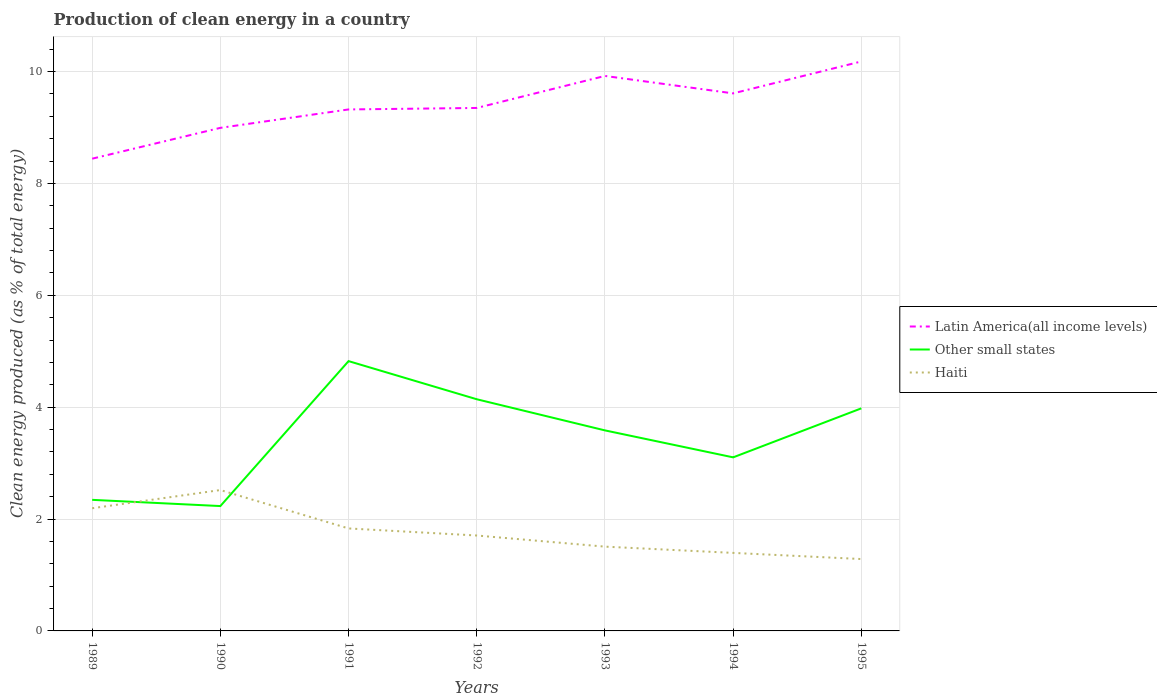Across all years, what is the maximum percentage of clean energy produced in Haiti?
Provide a succinct answer. 1.29. In which year was the percentage of clean energy produced in Latin America(all income levels) maximum?
Your answer should be compact. 1989. What is the total percentage of clean energy produced in Haiti in the graph?
Provide a short and direct response. 0.36. What is the difference between the highest and the second highest percentage of clean energy produced in Haiti?
Keep it short and to the point. 1.23. Is the percentage of clean energy produced in Other small states strictly greater than the percentage of clean energy produced in Latin America(all income levels) over the years?
Your answer should be compact. Yes. How many years are there in the graph?
Ensure brevity in your answer.  7. What is the difference between two consecutive major ticks on the Y-axis?
Your answer should be very brief. 2. Does the graph contain any zero values?
Offer a very short reply. No. Where does the legend appear in the graph?
Your response must be concise. Center right. How are the legend labels stacked?
Offer a very short reply. Vertical. What is the title of the graph?
Give a very brief answer. Production of clean energy in a country. What is the label or title of the Y-axis?
Your answer should be very brief. Clean energy produced (as % of total energy). What is the Clean energy produced (as % of total energy) of Latin America(all income levels) in 1989?
Give a very brief answer. 8.44. What is the Clean energy produced (as % of total energy) of Other small states in 1989?
Your answer should be very brief. 2.34. What is the Clean energy produced (as % of total energy) in Haiti in 1989?
Provide a short and direct response. 2.19. What is the Clean energy produced (as % of total energy) in Latin America(all income levels) in 1990?
Give a very brief answer. 8.99. What is the Clean energy produced (as % of total energy) of Other small states in 1990?
Ensure brevity in your answer.  2.23. What is the Clean energy produced (as % of total energy) in Haiti in 1990?
Your answer should be compact. 2.52. What is the Clean energy produced (as % of total energy) in Latin America(all income levels) in 1991?
Your answer should be compact. 9.32. What is the Clean energy produced (as % of total energy) in Other small states in 1991?
Make the answer very short. 4.82. What is the Clean energy produced (as % of total energy) in Haiti in 1991?
Your answer should be compact. 1.83. What is the Clean energy produced (as % of total energy) of Latin America(all income levels) in 1992?
Your answer should be very brief. 9.35. What is the Clean energy produced (as % of total energy) in Other small states in 1992?
Ensure brevity in your answer.  4.14. What is the Clean energy produced (as % of total energy) in Haiti in 1992?
Your answer should be compact. 1.71. What is the Clean energy produced (as % of total energy) in Latin America(all income levels) in 1993?
Your response must be concise. 9.92. What is the Clean energy produced (as % of total energy) of Other small states in 1993?
Your answer should be very brief. 3.59. What is the Clean energy produced (as % of total energy) in Haiti in 1993?
Your response must be concise. 1.51. What is the Clean energy produced (as % of total energy) of Latin America(all income levels) in 1994?
Ensure brevity in your answer.  9.61. What is the Clean energy produced (as % of total energy) in Other small states in 1994?
Keep it short and to the point. 3.1. What is the Clean energy produced (as % of total energy) of Haiti in 1994?
Your answer should be very brief. 1.39. What is the Clean energy produced (as % of total energy) of Latin America(all income levels) in 1995?
Offer a very short reply. 10.18. What is the Clean energy produced (as % of total energy) in Other small states in 1995?
Provide a short and direct response. 3.98. What is the Clean energy produced (as % of total energy) in Haiti in 1995?
Provide a short and direct response. 1.29. Across all years, what is the maximum Clean energy produced (as % of total energy) in Latin America(all income levels)?
Offer a very short reply. 10.18. Across all years, what is the maximum Clean energy produced (as % of total energy) in Other small states?
Your answer should be compact. 4.82. Across all years, what is the maximum Clean energy produced (as % of total energy) in Haiti?
Offer a terse response. 2.52. Across all years, what is the minimum Clean energy produced (as % of total energy) in Latin America(all income levels)?
Offer a very short reply. 8.44. Across all years, what is the minimum Clean energy produced (as % of total energy) in Other small states?
Provide a short and direct response. 2.23. Across all years, what is the minimum Clean energy produced (as % of total energy) of Haiti?
Offer a terse response. 1.29. What is the total Clean energy produced (as % of total energy) in Latin America(all income levels) in the graph?
Ensure brevity in your answer.  65.82. What is the total Clean energy produced (as % of total energy) of Other small states in the graph?
Provide a short and direct response. 24.21. What is the total Clean energy produced (as % of total energy) in Haiti in the graph?
Provide a succinct answer. 12.44. What is the difference between the Clean energy produced (as % of total energy) of Latin America(all income levels) in 1989 and that in 1990?
Give a very brief answer. -0.55. What is the difference between the Clean energy produced (as % of total energy) of Other small states in 1989 and that in 1990?
Keep it short and to the point. 0.11. What is the difference between the Clean energy produced (as % of total energy) of Haiti in 1989 and that in 1990?
Make the answer very short. -0.33. What is the difference between the Clean energy produced (as % of total energy) in Latin America(all income levels) in 1989 and that in 1991?
Offer a very short reply. -0.88. What is the difference between the Clean energy produced (as % of total energy) in Other small states in 1989 and that in 1991?
Offer a terse response. -2.48. What is the difference between the Clean energy produced (as % of total energy) in Haiti in 1989 and that in 1991?
Give a very brief answer. 0.36. What is the difference between the Clean energy produced (as % of total energy) of Latin America(all income levels) in 1989 and that in 1992?
Offer a very short reply. -0.91. What is the difference between the Clean energy produced (as % of total energy) in Other small states in 1989 and that in 1992?
Offer a terse response. -1.8. What is the difference between the Clean energy produced (as % of total energy) of Haiti in 1989 and that in 1992?
Your response must be concise. 0.49. What is the difference between the Clean energy produced (as % of total energy) in Latin America(all income levels) in 1989 and that in 1993?
Your answer should be very brief. -1.48. What is the difference between the Clean energy produced (as % of total energy) of Other small states in 1989 and that in 1993?
Keep it short and to the point. -1.24. What is the difference between the Clean energy produced (as % of total energy) of Haiti in 1989 and that in 1993?
Offer a very short reply. 0.69. What is the difference between the Clean energy produced (as % of total energy) of Latin America(all income levels) in 1989 and that in 1994?
Your answer should be compact. -1.17. What is the difference between the Clean energy produced (as % of total energy) of Other small states in 1989 and that in 1994?
Ensure brevity in your answer.  -0.76. What is the difference between the Clean energy produced (as % of total energy) in Haiti in 1989 and that in 1994?
Your answer should be compact. 0.8. What is the difference between the Clean energy produced (as % of total energy) of Latin America(all income levels) in 1989 and that in 1995?
Provide a succinct answer. -1.74. What is the difference between the Clean energy produced (as % of total energy) in Other small states in 1989 and that in 1995?
Give a very brief answer. -1.64. What is the difference between the Clean energy produced (as % of total energy) in Haiti in 1989 and that in 1995?
Provide a succinct answer. 0.91. What is the difference between the Clean energy produced (as % of total energy) of Latin America(all income levels) in 1990 and that in 1991?
Give a very brief answer. -0.33. What is the difference between the Clean energy produced (as % of total energy) of Other small states in 1990 and that in 1991?
Your answer should be very brief. -2.59. What is the difference between the Clean energy produced (as % of total energy) in Haiti in 1990 and that in 1991?
Make the answer very short. 0.69. What is the difference between the Clean energy produced (as % of total energy) in Latin America(all income levels) in 1990 and that in 1992?
Your response must be concise. -0.36. What is the difference between the Clean energy produced (as % of total energy) in Other small states in 1990 and that in 1992?
Your answer should be compact. -1.91. What is the difference between the Clean energy produced (as % of total energy) of Haiti in 1990 and that in 1992?
Keep it short and to the point. 0.81. What is the difference between the Clean energy produced (as % of total energy) in Latin America(all income levels) in 1990 and that in 1993?
Ensure brevity in your answer.  -0.93. What is the difference between the Clean energy produced (as % of total energy) in Other small states in 1990 and that in 1993?
Offer a very short reply. -1.35. What is the difference between the Clean energy produced (as % of total energy) of Haiti in 1990 and that in 1993?
Keep it short and to the point. 1.01. What is the difference between the Clean energy produced (as % of total energy) in Latin America(all income levels) in 1990 and that in 1994?
Keep it short and to the point. -0.62. What is the difference between the Clean energy produced (as % of total energy) in Other small states in 1990 and that in 1994?
Your response must be concise. -0.87. What is the difference between the Clean energy produced (as % of total energy) of Haiti in 1990 and that in 1994?
Give a very brief answer. 1.12. What is the difference between the Clean energy produced (as % of total energy) in Latin America(all income levels) in 1990 and that in 1995?
Ensure brevity in your answer.  -1.19. What is the difference between the Clean energy produced (as % of total energy) in Other small states in 1990 and that in 1995?
Your response must be concise. -1.75. What is the difference between the Clean energy produced (as % of total energy) of Haiti in 1990 and that in 1995?
Give a very brief answer. 1.23. What is the difference between the Clean energy produced (as % of total energy) of Latin America(all income levels) in 1991 and that in 1992?
Offer a terse response. -0.03. What is the difference between the Clean energy produced (as % of total energy) in Other small states in 1991 and that in 1992?
Make the answer very short. 0.68. What is the difference between the Clean energy produced (as % of total energy) of Haiti in 1991 and that in 1992?
Provide a succinct answer. 0.13. What is the difference between the Clean energy produced (as % of total energy) of Latin America(all income levels) in 1991 and that in 1993?
Offer a terse response. -0.6. What is the difference between the Clean energy produced (as % of total energy) of Other small states in 1991 and that in 1993?
Your answer should be compact. 1.24. What is the difference between the Clean energy produced (as % of total energy) of Haiti in 1991 and that in 1993?
Ensure brevity in your answer.  0.33. What is the difference between the Clean energy produced (as % of total energy) in Latin America(all income levels) in 1991 and that in 1994?
Offer a very short reply. -0.29. What is the difference between the Clean energy produced (as % of total energy) in Other small states in 1991 and that in 1994?
Provide a succinct answer. 1.72. What is the difference between the Clean energy produced (as % of total energy) of Haiti in 1991 and that in 1994?
Offer a terse response. 0.44. What is the difference between the Clean energy produced (as % of total energy) in Latin America(all income levels) in 1991 and that in 1995?
Offer a very short reply. -0.86. What is the difference between the Clean energy produced (as % of total energy) of Other small states in 1991 and that in 1995?
Offer a terse response. 0.84. What is the difference between the Clean energy produced (as % of total energy) of Haiti in 1991 and that in 1995?
Make the answer very short. 0.55. What is the difference between the Clean energy produced (as % of total energy) in Latin America(all income levels) in 1992 and that in 1993?
Provide a short and direct response. -0.57. What is the difference between the Clean energy produced (as % of total energy) of Other small states in 1992 and that in 1993?
Give a very brief answer. 0.56. What is the difference between the Clean energy produced (as % of total energy) of Haiti in 1992 and that in 1993?
Offer a terse response. 0.2. What is the difference between the Clean energy produced (as % of total energy) in Latin America(all income levels) in 1992 and that in 1994?
Offer a very short reply. -0.26. What is the difference between the Clean energy produced (as % of total energy) of Other small states in 1992 and that in 1994?
Ensure brevity in your answer.  1.04. What is the difference between the Clean energy produced (as % of total energy) of Haiti in 1992 and that in 1994?
Keep it short and to the point. 0.31. What is the difference between the Clean energy produced (as % of total energy) in Latin America(all income levels) in 1992 and that in 1995?
Keep it short and to the point. -0.83. What is the difference between the Clean energy produced (as % of total energy) of Other small states in 1992 and that in 1995?
Provide a short and direct response. 0.16. What is the difference between the Clean energy produced (as % of total energy) in Haiti in 1992 and that in 1995?
Offer a terse response. 0.42. What is the difference between the Clean energy produced (as % of total energy) in Latin America(all income levels) in 1993 and that in 1994?
Ensure brevity in your answer.  0.31. What is the difference between the Clean energy produced (as % of total energy) in Other small states in 1993 and that in 1994?
Offer a very short reply. 0.48. What is the difference between the Clean energy produced (as % of total energy) in Haiti in 1993 and that in 1994?
Make the answer very short. 0.11. What is the difference between the Clean energy produced (as % of total energy) in Latin America(all income levels) in 1993 and that in 1995?
Provide a succinct answer. -0.26. What is the difference between the Clean energy produced (as % of total energy) in Other small states in 1993 and that in 1995?
Keep it short and to the point. -0.39. What is the difference between the Clean energy produced (as % of total energy) of Haiti in 1993 and that in 1995?
Offer a terse response. 0.22. What is the difference between the Clean energy produced (as % of total energy) of Latin America(all income levels) in 1994 and that in 1995?
Ensure brevity in your answer.  -0.57. What is the difference between the Clean energy produced (as % of total energy) of Other small states in 1994 and that in 1995?
Offer a terse response. -0.88. What is the difference between the Clean energy produced (as % of total energy) in Haiti in 1994 and that in 1995?
Give a very brief answer. 0.11. What is the difference between the Clean energy produced (as % of total energy) in Latin America(all income levels) in 1989 and the Clean energy produced (as % of total energy) in Other small states in 1990?
Your answer should be compact. 6.21. What is the difference between the Clean energy produced (as % of total energy) in Latin America(all income levels) in 1989 and the Clean energy produced (as % of total energy) in Haiti in 1990?
Offer a very short reply. 5.92. What is the difference between the Clean energy produced (as % of total energy) in Other small states in 1989 and the Clean energy produced (as % of total energy) in Haiti in 1990?
Provide a short and direct response. -0.18. What is the difference between the Clean energy produced (as % of total energy) of Latin America(all income levels) in 1989 and the Clean energy produced (as % of total energy) of Other small states in 1991?
Your response must be concise. 3.62. What is the difference between the Clean energy produced (as % of total energy) in Latin America(all income levels) in 1989 and the Clean energy produced (as % of total energy) in Haiti in 1991?
Your answer should be compact. 6.61. What is the difference between the Clean energy produced (as % of total energy) in Other small states in 1989 and the Clean energy produced (as % of total energy) in Haiti in 1991?
Provide a succinct answer. 0.51. What is the difference between the Clean energy produced (as % of total energy) in Latin America(all income levels) in 1989 and the Clean energy produced (as % of total energy) in Other small states in 1992?
Your response must be concise. 4.3. What is the difference between the Clean energy produced (as % of total energy) in Latin America(all income levels) in 1989 and the Clean energy produced (as % of total energy) in Haiti in 1992?
Provide a succinct answer. 6.74. What is the difference between the Clean energy produced (as % of total energy) of Other small states in 1989 and the Clean energy produced (as % of total energy) of Haiti in 1992?
Your answer should be compact. 0.64. What is the difference between the Clean energy produced (as % of total energy) of Latin America(all income levels) in 1989 and the Clean energy produced (as % of total energy) of Other small states in 1993?
Provide a short and direct response. 4.86. What is the difference between the Clean energy produced (as % of total energy) of Latin America(all income levels) in 1989 and the Clean energy produced (as % of total energy) of Haiti in 1993?
Provide a short and direct response. 6.94. What is the difference between the Clean energy produced (as % of total energy) of Other small states in 1989 and the Clean energy produced (as % of total energy) of Haiti in 1993?
Offer a very short reply. 0.84. What is the difference between the Clean energy produced (as % of total energy) in Latin America(all income levels) in 1989 and the Clean energy produced (as % of total energy) in Other small states in 1994?
Make the answer very short. 5.34. What is the difference between the Clean energy produced (as % of total energy) in Latin America(all income levels) in 1989 and the Clean energy produced (as % of total energy) in Haiti in 1994?
Offer a terse response. 7.05. What is the difference between the Clean energy produced (as % of total energy) in Other small states in 1989 and the Clean energy produced (as % of total energy) in Haiti in 1994?
Ensure brevity in your answer.  0.95. What is the difference between the Clean energy produced (as % of total energy) in Latin America(all income levels) in 1989 and the Clean energy produced (as % of total energy) in Other small states in 1995?
Give a very brief answer. 4.46. What is the difference between the Clean energy produced (as % of total energy) of Latin America(all income levels) in 1989 and the Clean energy produced (as % of total energy) of Haiti in 1995?
Provide a succinct answer. 7.16. What is the difference between the Clean energy produced (as % of total energy) of Other small states in 1989 and the Clean energy produced (as % of total energy) of Haiti in 1995?
Make the answer very short. 1.06. What is the difference between the Clean energy produced (as % of total energy) of Latin America(all income levels) in 1990 and the Clean energy produced (as % of total energy) of Other small states in 1991?
Keep it short and to the point. 4.17. What is the difference between the Clean energy produced (as % of total energy) in Latin America(all income levels) in 1990 and the Clean energy produced (as % of total energy) in Haiti in 1991?
Give a very brief answer. 7.16. What is the difference between the Clean energy produced (as % of total energy) of Other small states in 1990 and the Clean energy produced (as % of total energy) of Haiti in 1991?
Provide a short and direct response. 0.4. What is the difference between the Clean energy produced (as % of total energy) in Latin America(all income levels) in 1990 and the Clean energy produced (as % of total energy) in Other small states in 1992?
Your answer should be compact. 4.85. What is the difference between the Clean energy produced (as % of total energy) in Latin America(all income levels) in 1990 and the Clean energy produced (as % of total energy) in Haiti in 1992?
Ensure brevity in your answer.  7.29. What is the difference between the Clean energy produced (as % of total energy) in Other small states in 1990 and the Clean energy produced (as % of total energy) in Haiti in 1992?
Offer a very short reply. 0.53. What is the difference between the Clean energy produced (as % of total energy) of Latin America(all income levels) in 1990 and the Clean energy produced (as % of total energy) of Other small states in 1993?
Provide a short and direct response. 5.41. What is the difference between the Clean energy produced (as % of total energy) in Latin America(all income levels) in 1990 and the Clean energy produced (as % of total energy) in Haiti in 1993?
Offer a terse response. 7.49. What is the difference between the Clean energy produced (as % of total energy) of Other small states in 1990 and the Clean energy produced (as % of total energy) of Haiti in 1993?
Give a very brief answer. 0.73. What is the difference between the Clean energy produced (as % of total energy) of Latin America(all income levels) in 1990 and the Clean energy produced (as % of total energy) of Other small states in 1994?
Your response must be concise. 5.89. What is the difference between the Clean energy produced (as % of total energy) in Latin America(all income levels) in 1990 and the Clean energy produced (as % of total energy) in Haiti in 1994?
Keep it short and to the point. 7.6. What is the difference between the Clean energy produced (as % of total energy) in Other small states in 1990 and the Clean energy produced (as % of total energy) in Haiti in 1994?
Ensure brevity in your answer.  0.84. What is the difference between the Clean energy produced (as % of total energy) of Latin America(all income levels) in 1990 and the Clean energy produced (as % of total energy) of Other small states in 1995?
Offer a very short reply. 5.01. What is the difference between the Clean energy produced (as % of total energy) of Latin America(all income levels) in 1990 and the Clean energy produced (as % of total energy) of Haiti in 1995?
Your answer should be very brief. 7.71. What is the difference between the Clean energy produced (as % of total energy) of Other small states in 1990 and the Clean energy produced (as % of total energy) of Haiti in 1995?
Keep it short and to the point. 0.95. What is the difference between the Clean energy produced (as % of total energy) in Latin America(all income levels) in 1991 and the Clean energy produced (as % of total energy) in Other small states in 1992?
Give a very brief answer. 5.18. What is the difference between the Clean energy produced (as % of total energy) in Latin America(all income levels) in 1991 and the Clean energy produced (as % of total energy) in Haiti in 1992?
Your answer should be compact. 7.62. What is the difference between the Clean energy produced (as % of total energy) in Other small states in 1991 and the Clean energy produced (as % of total energy) in Haiti in 1992?
Provide a short and direct response. 3.12. What is the difference between the Clean energy produced (as % of total energy) of Latin America(all income levels) in 1991 and the Clean energy produced (as % of total energy) of Other small states in 1993?
Provide a short and direct response. 5.74. What is the difference between the Clean energy produced (as % of total energy) in Latin America(all income levels) in 1991 and the Clean energy produced (as % of total energy) in Haiti in 1993?
Provide a succinct answer. 7.82. What is the difference between the Clean energy produced (as % of total energy) of Other small states in 1991 and the Clean energy produced (as % of total energy) of Haiti in 1993?
Your answer should be compact. 3.32. What is the difference between the Clean energy produced (as % of total energy) of Latin America(all income levels) in 1991 and the Clean energy produced (as % of total energy) of Other small states in 1994?
Your answer should be compact. 6.22. What is the difference between the Clean energy produced (as % of total energy) in Latin America(all income levels) in 1991 and the Clean energy produced (as % of total energy) in Haiti in 1994?
Your response must be concise. 7.93. What is the difference between the Clean energy produced (as % of total energy) of Other small states in 1991 and the Clean energy produced (as % of total energy) of Haiti in 1994?
Keep it short and to the point. 3.43. What is the difference between the Clean energy produced (as % of total energy) of Latin America(all income levels) in 1991 and the Clean energy produced (as % of total energy) of Other small states in 1995?
Offer a very short reply. 5.34. What is the difference between the Clean energy produced (as % of total energy) in Latin America(all income levels) in 1991 and the Clean energy produced (as % of total energy) in Haiti in 1995?
Offer a very short reply. 8.04. What is the difference between the Clean energy produced (as % of total energy) of Other small states in 1991 and the Clean energy produced (as % of total energy) of Haiti in 1995?
Keep it short and to the point. 3.54. What is the difference between the Clean energy produced (as % of total energy) of Latin America(all income levels) in 1992 and the Clean energy produced (as % of total energy) of Other small states in 1993?
Your answer should be compact. 5.76. What is the difference between the Clean energy produced (as % of total energy) of Latin America(all income levels) in 1992 and the Clean energy produced (as % of total energy) of Haiti in 1993?
Make the answer very short. 7.84. What is the difference between the Clean energy produced (as % of total energy) of Other small states in 1992 and the Clean energy produced (as % of total energy) of Haiti in 1993?
Provide a short and direct response. 2.63. What is the difference between the Clean energy produced (as % of total energy) in Latin America(all income levels) in 1992 and the Clean energy produced (as % of total energy) in Other small states in 1994?
Offer a terse response. 6.25. What is the difference between the Clean energy produced (as % of total energy) of Latin America(all income levels) in 1992 and the Clean energy produced (as % of total energy) of Haiti in 1994?
Your response must be concise. 7.95. What is the difference between the Clean energy produced (as % of total energy) of Other small states in 1992 and the Clean energy produced (as % of total energy) of Haiti in 1994?
Provide a succinct answer. 2.75. What is the difference between the Clean energy produced (as % of total energy) of Latin America(all income levels) in 1992 and the Clean energy produced (as % of total energy) of Other small states in 1995?
Your answer should be very brief. 5.37. What is the difference between the Clean energy produced (as % of total energy) in Latin America(all income levels) in 1992 and the Clean energy produced (as % of total energy) in Haiti in 1995?
Your answer should be very brief. 8.06. What is the difference between the Clean energy produced (as % of total energy) of Other small states in 1992 and the Clean energy produced (as % of total energy) of Haiti in 1995?
Offer a terse response. 2.86. What is the difference between the Clean energy produced (as % of total energy) of Latin America(all income levels) in 1993 and the Clean energy produced (as % of total energy) of Other small states in 1994?
Ensure brevity in your answer.  6.82. What is the difference between the Clean energy produced (as % of total energy) in Latin America(all income levels) in 1993 and the Clean energy produced (as % of total energy) in Haiti in 1994?
Make the answer very short. 8.53. What is the difference between the Clean energy produced (as % of total energy) in Other small states in 1993 and the Clean energy produced (as % of total energy) in Haiti in 1994?
Your answer should be very brief. 2.19. What is the difference between the Clean energy produced (as % of total energy) of Latin America(all income levels) in 1993 and the Clean energy produced (as % of total energy) of Other small states in 1995?
Your response must be concise. 5.94. What is the difference between the Clean energy produced (as % of total energy) in Latin America(all income levels) in 1993 and the Clean energy produced (as % of total energy) in Haiti in 1995?
Provide a succinct answer. 8.64. What is the difference between the Clean energy produced (as % of total energy) of Latin America(all income levels) in 1994 and the Clean energy produced (as % of total energy) of Other small states in 1995?
Offer a terse response. 5.63. What is the difference between the Clean energy produced (as % of total energy) of Latin America(all income levels) in 1994 and the Clean energy produced (as % of total energy) of Haiti in 1995?
Offer a very short reply. 8.32. What is the difference between the Clean energy produced (as % of total energy) of Other small states in 1994 and the Clean energy produced (as % of total energy) of Haiti in 1995?
Make the answer very short. 1.82. What is the average Clean energy produced (as % of total energy) of Latin America(all income levels) per year?
Your answer should be very brief. 9.4. What is the average Clean energy produced (as % of total energy) of Other small states per year?
Your answer should be compact. 3.46. What is the average Clean energy produced (as % of total energy) of Haiti per year?
Your response must be concise. 1.78. In the year 1989, what is the difference between the Clean energy produced (as % of total energy) of Latin America(all income levels) and Clean energy produced (as % of total energy) of Other small states?
Keep it short and to the point. 6.1. In the year 1989, what is the difference between the Clean energy produced (as % of total energy) in Latin America(all income levels) and Clean energy produced (as % of total energy) in Haiti?
Offer a terse response. 6.25. In the year 1989, what is the difference between the Clean energy produced (as % of total energy) in Other small states and Clean energy produced (as % of total energy) in Haiti?
Provide a succinct answer. 0.15. In the year 1990, what is the difference between the Clean energy produced (as % of total energy) of Latin America(all income levels) and Clean energy produced (as % of total energy) of Other small states?
Your response must be concise. 6.76. In the year 1990, what is the difference between the Clean energy produced (as % of total energy) of Latin America(all income levels) and Clean energy produced (as % of total energy) of Haiti?
Offer a terse response. 6.47. In the year 1990, what is the difference between the Clean energy produced (as % of total energy) of Other small states and Clean energy produced (as % of total energy) of Haiti?
Give a very brief answer. -0.29. In the year 1991, what is the difference between the Clean energy produced (as % of total energy) of Latin America(all income levels) and Clean energy produced (as % of total energy) of Other small states?
Your answer should be very brief. 4.5. In the year 1991, what is the difference between the Clean energy produced (as % of total energy) of Latin America(all income levels) and Clean energy produced (as % of total energy) of Haiti?
Offer a terse response. 7.49. In the year 1991, what is the difference between the Clean energy produced (as % of total energy) of Other small states and Clean energy produced (as % of total energy) of Haiti?
Your answer should be very brief. 2.99. In the year 1992, what is the difference between the Clean energy produced (as % of total energy) in Latin America(all income levels) and Clean energy produced (as % of total energy) in Other small states?
Provide a short and direct response. 5.21. In the year 1992, what is the difference between the Clean energy produced (as % of total energy) of Latin America(all income levels) and Clean energy produced (as % of total energy) of Haiti?
Make the answer very short. 7.64. In the year 1992, what is the difference between the Clean energy produced (as % of total energy) in Other small states and Clean energy produced (as % of total energy) in Haiti?
Your answer should be very brief. 2.44. In the year 1993, what is the difference between the Clean energy produced (as % of total energy) of Latin America(all income levels) and Clean energy produced (as % of total energy) of Other small states?
Make the answer very short. 6.34. In the year 1993, what is the difference between the Clean energy produced (as % of total energy) in Latin America(all income levels) and Clean energy produced (as % of total energy) in Haiti?
Make the answer very short. 8.41. In the year 1993, what is the difference between the Clean energy produced (as % of total energy) of Other small states and Clean energy produced (as % of total energy) of Haiti?
Offer a very short reply. 2.08. In the year 1994, what is the difference between the Clean energy produced (as % of total energy) in Latin America(all income levels) and Clean energy produced (as % of total energy) in Other small states?
Give a very brief answer. 6.51. In the year 1994, what is the difference between the Clean energy produced (as % of total energy) of Latin America(all income levels) and Clean energy produced (as % of total energy) of Haiti?
Provide a succinct answer. 8.21. In the year 1994, what is the difference between the Clean energy produced (as % of total energy) in Other small states and Clean energy produced (as % of total energy) in Haiti?
Provide a short and direct response. 1.71. In the year 1995, what is the difference between the Clean energy produced (as % of total energy) in Latin America(all income levels) and Clean energy produced (as % of total energy) in Other small states?
Make the answer very short. 6.2. In the year 1995, what is the difference between the Clean energy produced (as % of total energy) of Latin America(all income levels) and Clean energy produced (as % of total energy) of Haiti?
Give a very brief answer. 8.9. In the year 1995, what is the difference between the Clean energy produced (as % of total energy) in Other small states and Clean energy produced (as % of total energy) in Haiti?
Give a very brief answer. 2.69. What is the ratio of the Clean energy produced (as % of total energy) in Latin America(all income levels) in 1989 to that in 1990?
Keep it short and to the point. 0.94. What is the ratio of the Clean energy produced (as % of total energy) in Other small states in 1989 to that in 1990?
Your answer should be very brief. 1.05. What is the ratio of the Clean energy produced (as % of total energy) of Haiti in 1989 to that in 1990?
Your answer should be very brief. 0.87. What is the ratio of the Clean energy produced (as % of total energy) of Latin America(all income levels) in 1989 to that in 1991?
Ensure brevity in your answer.  0.91. What is the ratio of the Clean energy produced (as % of total energy) of Other small states in 1989 to that in 1991?
Offer a very short reply. 0.49. What is the ratio of the Clean energy produced (as % of total energy) in Haiti in 1989 to that in 1991?
Your response must be concise. 1.2. What is the ratio of the Clean energy produced (as % of total energy) in Latin America(all income levels) in 1989 to that in 1992?
Provide a succinct answer. 0.9. What is the ratio of the Clean energy produced (as % of total energy) in Other small states in 1989 to that in 1992?
Keep it short and to the point. 0.57. What is the ratio of the Clean energy produced (as % of total energy) of Haiti in 1989 to that in 1992?
Offer a very short reply. 1.29. What is the ratio of the Clean energy produced (as % of total energy) in Latin America(all income levels) in 1989 to that in 1993?
Your answer should be compact. 0.85. What is the ratio of the Clean energy produced (as % of total energy) of Other small states in 1989 to that in 1993?
Your response must be concise. 0.65. What is the ratio of the Clean energy produced (as % of total energy) of Haiti in 1989 to that in 1993?
Keep it short and to the point. 1.46. What is the ratio of the Clean energy produced (as % of total energy) of Latin America(all income levels) in 1989 to that in 1994?
Your answer should be very brief. 0.88. What is the ratio of the Clean energy produced (as % of total energy) in Other small states in 1989 to that in 1994?
Give a very brief answer. 0.76. What is the ratio of the Clean energy produced (as % of total energy) of Haiti in 1989 to that in 1994?
Ensure brevity in your answer.  1.57. What is the ratio of the Clean energy produced (as % of total energy) in Latin America(all income levels) in 1989 to that in 1995?
Offer a very short reply. 0.83. What is the ratio of the Clean energy produced (as % of total energy) of Other small states in 1989 to that in 1995?
Ensure brevity in your answer.  0.59. What is the ratio of the Clean energy produced (as % of total energy) in Haiti in 1989 to that in 1995?
Keep it short and to the point. 1.71. What is the ratio of the Clean energy produced (as % of total energy) in Latin America(all income levels) in 1990 to that in 1991?
Ensure brevity in your answer.  0.96. What is the ratio of the Clean energy produced (as % of total energy) of Other small states in 1990 to that in 1991?
Provide a short and direct response. 0.46. What is the ratio of the Clean energy produced (as % of total energy) in Haiti in 1990 to that in 1991?
Your response must be concise. 1.37. What is the ratio of the Clean energy produced (as % of total energy) in Latin America(all income levels) in 1990 to that in 1992?
Make the answer very short. 0.96. What is the ratio of the Clean energy produced (as % of total energy) of Other small states in 1990 to that in 1992?
Provide a succinct answer. 0.54. What is the ratio of the Clean energy produced (as % of total energy) in Haiti in 1990 to that in 1992?
Make the answer very short. 1.48. What is the ratio of the Clean energy produced (as % of total energy) of Latin America(all income levels) in 1990 to that in 1993?
Keep it short and to the point. 0.91. What is the ratio of the Clean energy produced (as % of total energy) of Other small states in 1990 to that in 1993?
Your answer should be compact. 0.62. What is the ratio of the Clean energy produced (as % of total energy) of Haiti in 1990 to that in 1993?
Provide a short and direct response. 1.67. What is the ratio of the Clean energy produced (as % of total energy) of Latin America(all income levels) in 1990 to that in 1994?
Provide a succinct answer. 0.94. What is the ratio of the Clean energy produced (as % of total energy) of Other small states in 1990 to that in 1994?
Provide a short and direct response. 0.72. What is the ratio of the Clean energy produced (as % of total energy) in Haiti in 1990 to that in 1994?
Keep it short and to the point. 1.81. What is the ratio of the Clean energy produced (as % of total energy) of Latin America(all income levels) in 1990 to that in 1995?
Your answer should be very brief. 0.88. What is the ratio of the Clean energy produced (as % of total energy) of Other small states in 1990 to that in 1995?
Offer a terse response. 0.56. What is the ratio of the Clean energy produced (as % of total energy) of Haiti in 1990 to that in 1995?
Ensure brevity in your answer.  1.96. What is the ratio of the Clean energy produced (as % of total energy) of Other small states in 1991 to that in 1992?
Ensure brevity in your answer.  1.16. What is the ratio of the Clean energy produced (as % of total energy) of Haiti in 1991 to that in 1992?
Keep it short and to the point. 1.07. What is the ratio of the Clean energy produced (as % of total energy) in Latin America(all income levels) in 1991 to that in 1993?
Your response must be concise. 0.94. What is the ratio of the Clean energy produced (as % of total energy) in Other small states in 1991 to that in 1993?
Provide a short and direct response. 1.35. What is the ratio of the Clean energy produced (as % of total energy) of Haiti in 1991 to that in 1993?
Your answer should be compact. 1.22. What is the ratio of the Clean energy produced (as % of total energy) in Latin America(all income levels) in 1991 to that in 1994?
Ensure brevity in your answer.  0.97. What is the ratio of the Clean energy produced (as % of total energy) of Other small states in 1991 to that in 1994?
Your answer should be very brief. 1.55. What is the ratio of the Clean energy produced (as % of total energy) in Haiti in 1991 to that in 1994?
Provide a short and direct response. 1.31. What is the ratio of the Clean energy produced (as % of total energy) in Latin America(all income levels) in 1991 to that in 1995?
Ensure brevity in your answer.  0.92. What is the ratio of the Clean energy produced (as % of total energy) of Other small states in 1991 to that in 1995?
Ensure brevity in your answer.  1.21. What is the ratio of the Clean energy produced (as % of total energy) of Haiti in 1991 to that in 1995?
Your answer should be compact. 1.43. What is the ratio of the Clean energy produced (as % of total energy) in Latin America(all income levels) in 1992 to that in 1993?
Your response must be concise. 0.94. What is the ratio of the Clean energy produced (as % of total energy) of Other small states in 1992 to that in 1993?
Keep it short and to the point. 1.16. What is the ratio of the Clean energy produced (as % of total energy) of Haiti in 1992 to that in 1993?
Provide a succinct answer. 1.13. What is the ratio of the Clean energy produced (as % of total energy) of Latin America(all income levels) in 1992 to that in 1994?
Offer a very short reply. 0.97. What is the ratio of the Clean energy produced (as % of total energy) in Other small states in 1992 to that in 1994?
Provide a succinct answer. 1.33. What is the ratio of the Clean energy produced (as % of total energy) in Haiti in 1992 to that in 1994?
Offer a terse response. 1.22. What is the ratio of the Clean energy produced (as % of total energy) in Latin America(all income levels) in 1992 to that in 1995?
Give a very brief answer. 0.92. What is the ratio of the Clean energy produced (as % of total energy) of Other small states in 1992 to that in 1995?
Your answer should be compact. 1.04. What is the ratio of the Clean energy produced (as % of total energy) in Haiti in 1992 to that in 1995?
Offer a very short reply. 1.33. What is the ratio of the Clean energy produced (as % of total energy) in Latin America(all income levels) in 1993 to that in 1994?
Make the answer very short. 1.03. What is the ratio of the Clean energy produced (as % of total energy) in Other small states in 1993 to that in 1994?
Offer a very short reply. 1.16. What is the ratio of the Clean energy produced (as % of total energy) in Haiti in 1993 to that in 1994?
Give a very brief answer. 1.08. What is the ratio of the Clean energy produced (as % of total energy) of Latin America(all income levels) in 1993 to that in 1995?
Provide a short and direct response. 0.97. What is the ratio of the Clean energy produced (as % of total energy) of Other small states in 1993 to that in 1995?
Make the answer very short. 0.9. What is the ratio of the Clean energy produced (as % of total energy) in Haiti in 1993 to that in 1995?
Offer a terse response. 1.17. What is the ratio of the Clean energy produced (as % of total energy) of Latin America(all income levels) in 1994 to that in 1995?
Your answer should be very brief. 0.94. What is the ratio of the Clean energy produced (as % of total energy) of Other small states in 1994 to that in 1995?
Make the answer very short. 0.78. What is the ratio of the Clean energy produced (as % of total energy) of Haiti in 1994 to that in 1995?
Your answer should be very brief. 1.09. What is the difference between the highest and the second highest Clean energy produced (as % of total energy) in Latin America(all income levels)?
Offer a very short reply. 0.26. What is the difference between the highest and the second highest Clean energy produced (as % of total energy) in Other small states?
Ensure brevity in your answer.  0.68. What is the difference between the highest and the second highest Clean energy produced (as % of total energy) in Haiti?
Your response must be concise. 0.33. What is the difference between the highest and the lowest Clean energy produced (as % of total energy) of Latin America(all income levels)?
Your response must be concise. 1.74. What is the difference between the highest and the lowest Clean energy produced (as % of total energy) in Other small states?
Ensure brevity in your answer.  2.59. What is the difference between the highest and the lowest Clean energy produced (as % of total energy) of Haiti?
Your response must be concise. 1.23. 